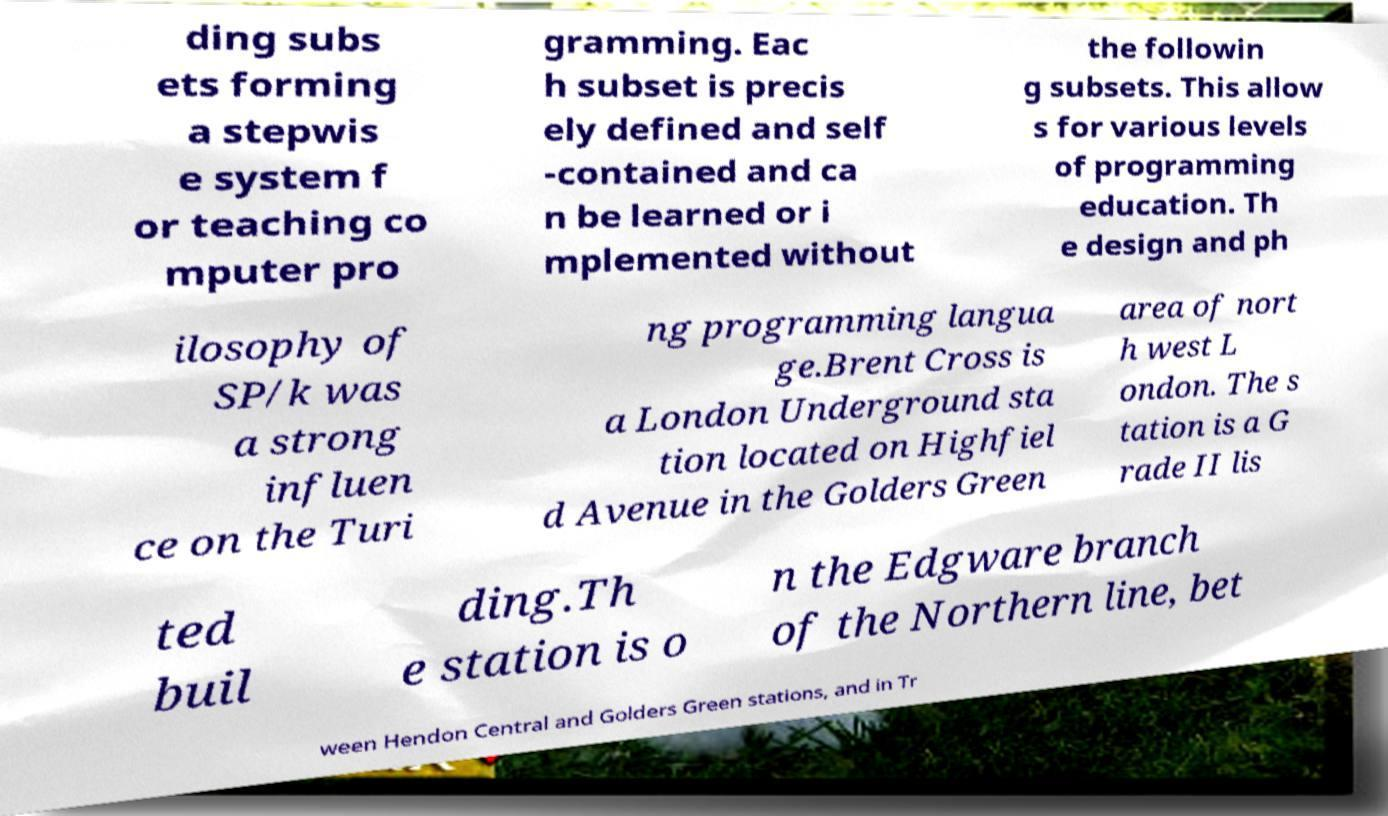Please read and relay the text visible in this image. What does it say? ding subs ets forming a stepwis e system f or teaching co mputer pro gramming. Eac h subset is precis ely defined and self -contained and ca n be learned or i mplemented without the followin g subsets. This allow s for various levels of programming education. Th e design and ph ilosophy of SP/k was a strong influen ce on the Turi ng programming langua ge.Brent Cross is a London Underground sta tion located on Highfiel d Avenue in the Golders Green area of nort h west L ondon. The s tation is a G rade II lis ted buil ding.Th e station is o n the Edgware branch of the Northern line, bet ween Hendon Central and Golders Green stations, and in Tr 